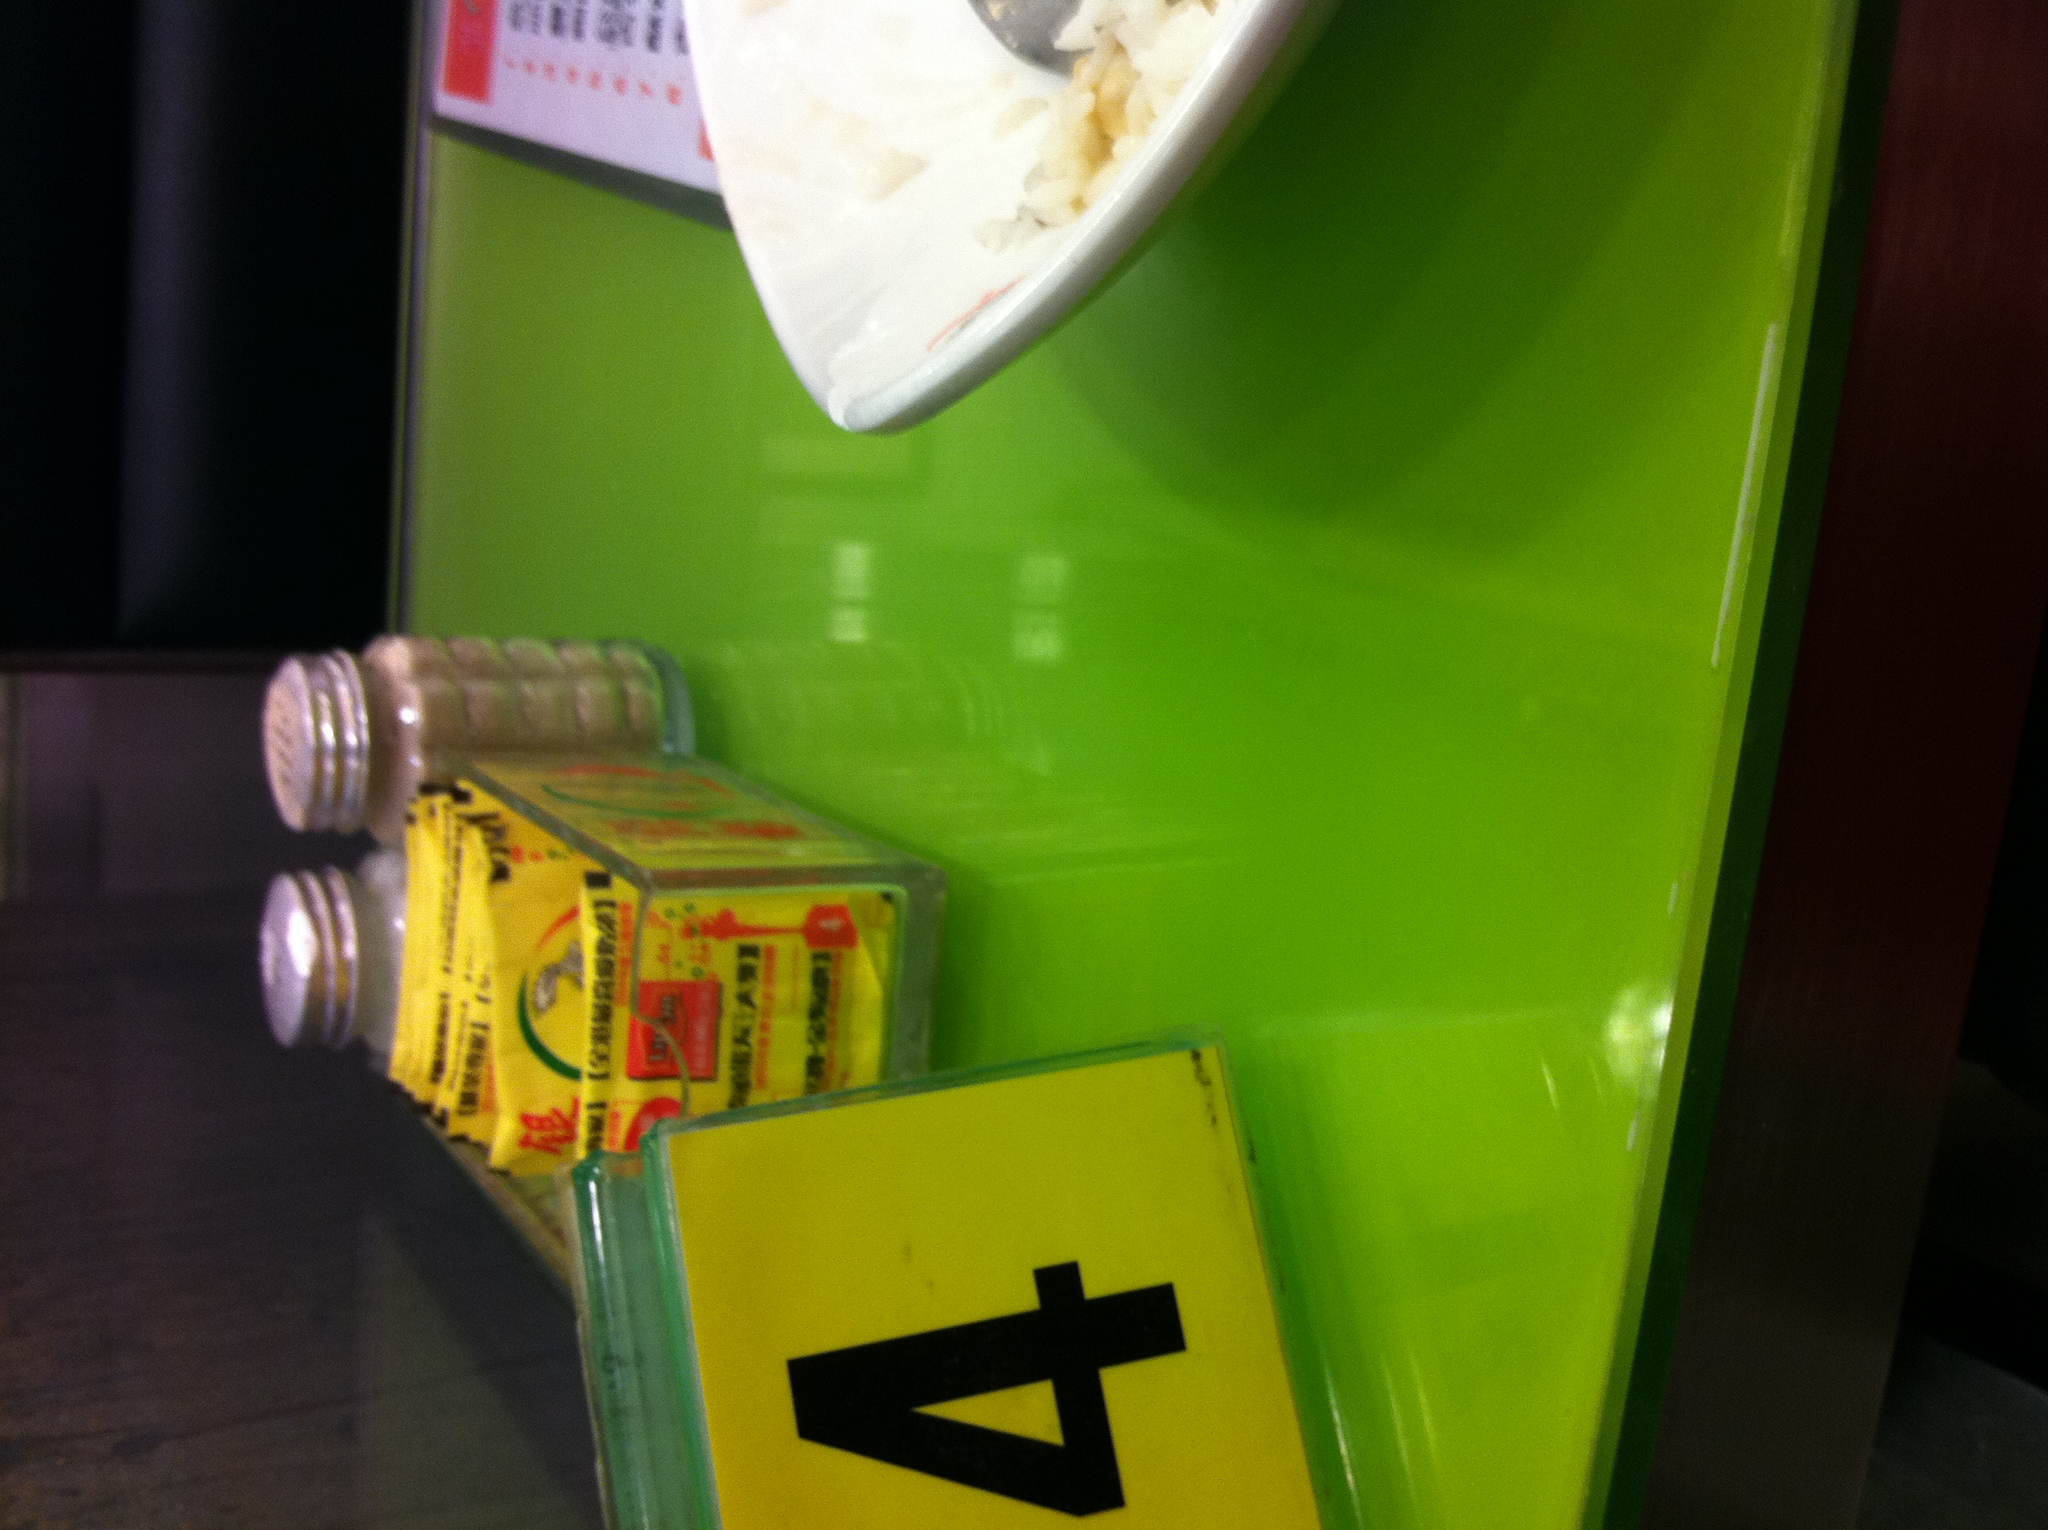Write a short scenario that might happen at this table. A young couple sits down at table number 4. They look at each other hesitantly, with the guy nervously fidgeting with the salt shaker. They attempt small talk about the food and the ambiance while waiting for their order. It's their first date, and they use this cozy meal to learn more about each other, sharing stories and experiences, slowly easing into comfort and laughter. 